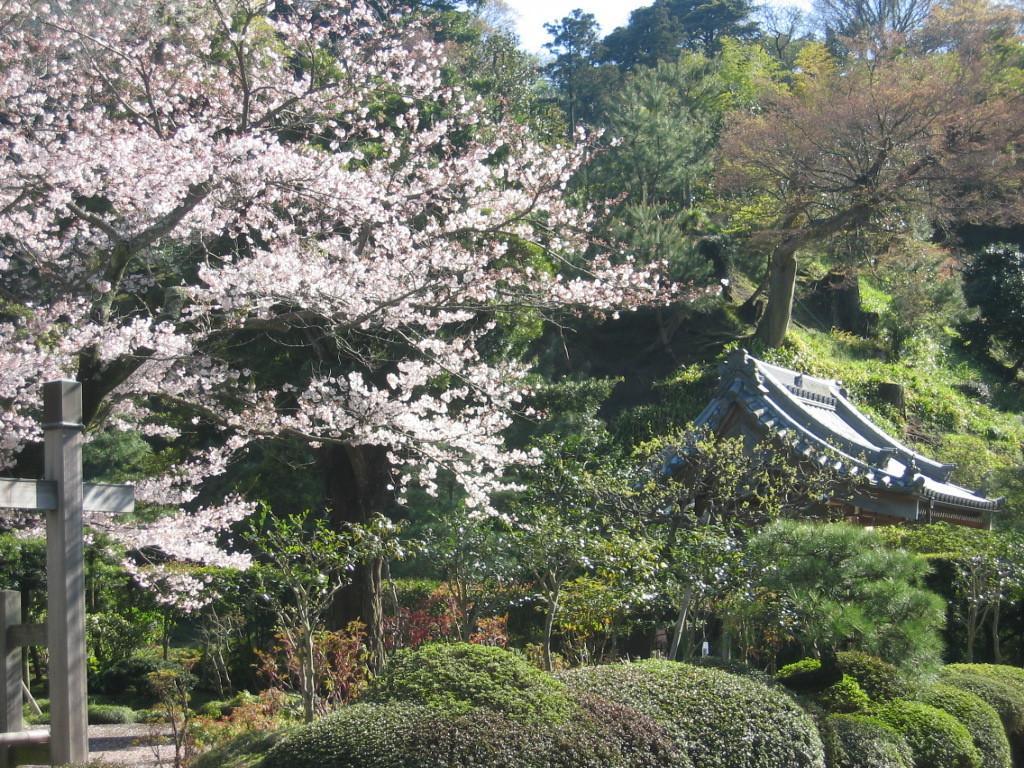How would you summarize this image in a sentence or two? This image is taken outdoors. In this image there are many trees and plants with flowers, green leaves, stems and branches. On the right side of the image there is a Chinese architecture with walls and a roof. On the left side of the image there are a few iron bars. 